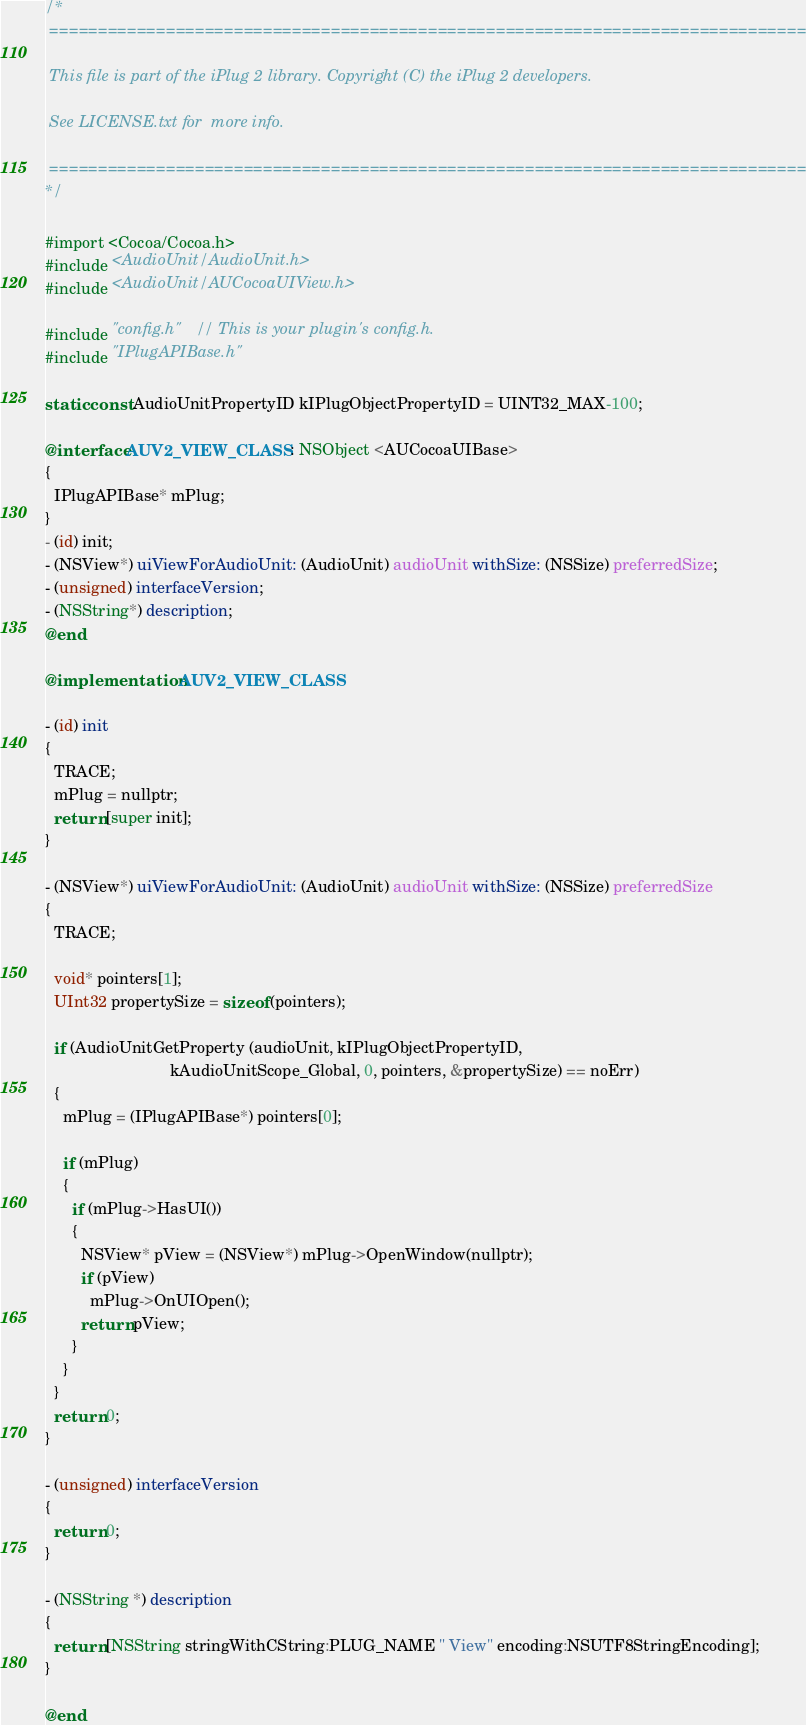<code> <loc_0><loc_0><loc_500><loc_500><_ObjectiveC_>/*
 ==============================================================================
 
 This file is part of the iPlug 2 library. Copyright (C) the iPlug 2 developers. 
 
 See LICENSE.txt for  more info.
 
 ==============================================================================
*/
 
#import <Cocoa/Cocoa.h>
#include <AudioUnit/AudioUnit.h>
#include <AudioUnit/AUCocoaUIView.h>

#include "config.h"   // This is your plugin's config.h.
#include "IPlugAPIBase.h"

static const AudioUnitPropertyID kIPlugObjectPropertyID = UINT32_MAX-100;

@interface AUV2_VIEW_CLASS : NSObject <AUCocoaUIBase>
{
  IPlugAPIBase* mPlug;
}
- (id) init;
- (NSView*) uiViewForAudioUnit: (AudioUnit) audioUnit withSize: (NSSize) preferredSize;
- (unsigned) interfaceVersion;
- (NSString*) description;
@end

@implementation AUV2_VIEW_CLASS

- (id) init
{
  TRACE;  
  mPlug = nullptr;
  return [super init];
}

- (NSView*) uiViewForAudioUnit: (AudioUnit) audioUnit withSize: (NSSize) preferredSize
{
  TRACE;

  void* pointers[1];
  UInt32 propertySize = sizeof (pointers);
  
  if (AudioUnitGetProperty (audioUnit, kIPlugObjectPropertyID,
                            kAudioUnitScope_Global, 0, pointers, &propertySize) == noErr)
  {
    mPlug = (IPlugAPIBase*) pointers[0];
    
    if (mPlug)
    {
      if (mPlug->HasUI())
      {
        NSView* pView = (NSView*) mPlug->OpenWindow(nullptr);
        if (pView)
          mPlug->OnUIOpen();
        return pView;
      }
    }
  }
  return 0;
}

- (unsigned) interfaceVersion
{
  return 0;
}

- (NSString *) description
{
  return [NSString stringWithCString:PLUG_NAME " View" encoding:NSUTF8StringEncoding];
}

@end


</code> 